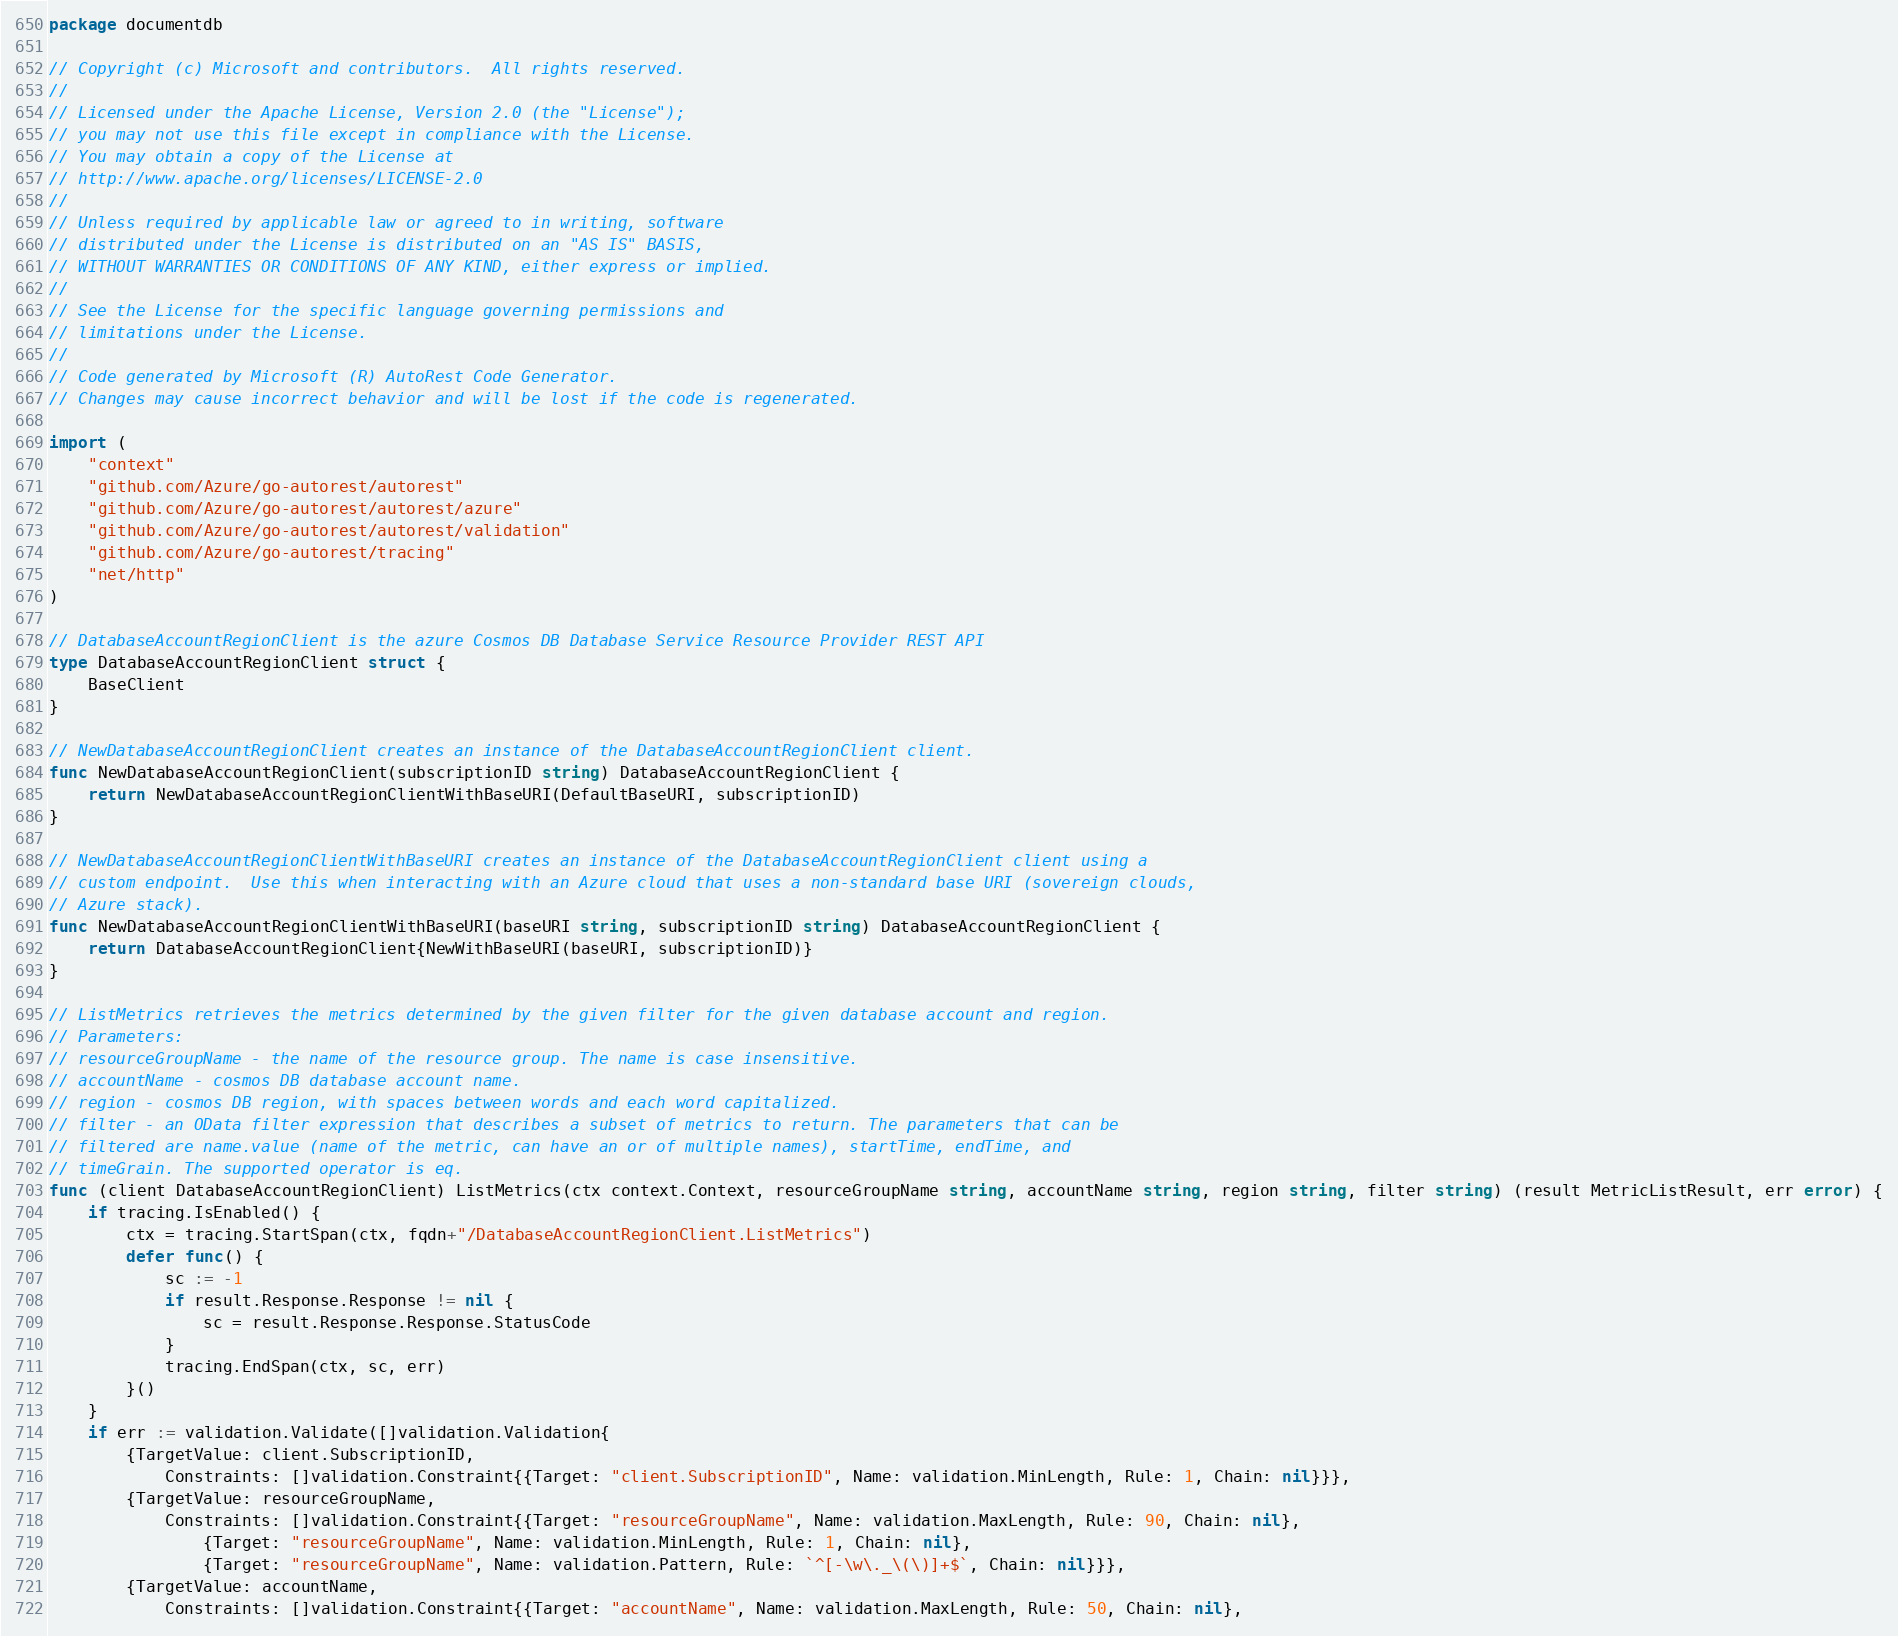Convert code to text. <code><loc_0><loc_0><loc_500><loc_500><_Go_>package documentdb

// Copyright (c) Microsoft and contributors.  All rights reserved.
//
// Licensed under the Apache License, Version 2.0 (the "License");
// you may not use this file except in compliance with the License.
// You may obtain a copy of the License at
// http://www.apache.org/licenses/LICENSE-2.0
//
// Unless required by applicable law or agreed to in writing, software
// distributed under the License is distributed on an "AS IS" BASIS,
// WITHOUT WARRANTIES OR CONDITIONS OF ANY KIND, either express or implied.
//
// See the License for the specific language governing permissions and
// limitations under the License.
//
// Code generated by Microsoft (R) AutoRest Code Generator.
// Changes may cause incorrect behavior and will be lost if the code is regenerated.

import (
	"context"
	"github.com/Azure/go-autorest/autorest"
	"github.com/Azure/go-autorest/autorest/azure"
	"github.com/Azure/go-autorest/autorest/validation"
	"github.com/Azure/go-autorest/tracing"
	"net/http"
)

// DatabaseAccountRegionClient is the azure Cosmos DB Database Service Resource Provider REST API
type DatabaseAccountRegionClient struct {
	BaseClient
}

// NewDatabaseAccountRegionClient creates an instance of the DatabaseAccountRegionClient client.
func NewDatabaseAccountRegionClient(subscriptionID string) DatabaseAccountRegionClient {
	return NewDatabaseAccountRegionClientWithBaseURI(DefaultBaseURI, subscriptionID)
}

// NewDatabaseAccountRegionClientWithBaseURI creates an instance of the DatabaseAccountRegionClient client using a
// custom endpoint.  Use this when interacting with an Azure cloud that uses a non-standard base URI (sovereign clouds,
// Azure stack).
func NewDatabaseAccountRegionClientWithBaseURI(baseURI string, subscriptionID string) DatabaseAccountRegionClient {
	return DatabaseAccountRegionClient{NewWithBaseURI(baseURI, subscriptionID)}
}

// ListMetrics retrieves the metrics determined by the given filter for the given database account and region.
// Parameters:
// resourceGroupName - the name of the resource group. The name is case insensitive.
// accountName - cosmos DB database account name.
// region - cosmos DB region, with spaces between words and each word capitalized.
// filter - an OData filter expression that describes a subset of metrics to return. The parameters that can be
// filtered are name.value (name of the metric, can have an or of multiple names), startTime, endTime, and
// timeGrain. The supported operator is eq.
func (client DatabaseAccountRegionClient) ListMetrics(ctx context.Context, resourceGroupName string, accountName string, region string, filter string) (result MetricListResult, err error) {
	if tracing.IsEnabled() {
		ctx = tracing.StartSpan(ctx, fqdn+"/DatabaseAccountRegionClient.ListMetrics")
		defer func() {
			sc := -1
			if result.Response.Response != nil {
				sc = result.Response.Response.StatusCode
			}
			tracing.EndSpan(ctx, sc, err)
		}()
	}
	if err := validation.Validate([]validation.Validation{
		{TargetValue: client.SubscriptionID,
			Constraints: []validation.Constraint{{Target: "client.SubscriptionID", Name: validation.MinLength, Rule: 1, Chain: nil}}},
		{TargetValue: resourceGroupName,
			Constraints: []validation.Constraint{{Target: "resourceGroupName", Name: validation.MaxLength, Rule: 90, Chain: nil},
				{Target: "resourceGroupName", Name: validation.MinLength, Rule: 1, Chain: nil},
				{Target: "resourceGroupName", Name: validation.Pattern, Rule: `^[-\w\._\(\)]+$`, Chain: nil}}},
		{TargetValue: accountName,
			Constraints: []validation.Constraint{{Target: "accountName", Name: validation.MaxLength, Rule: 50, Chain: nil},</code> 